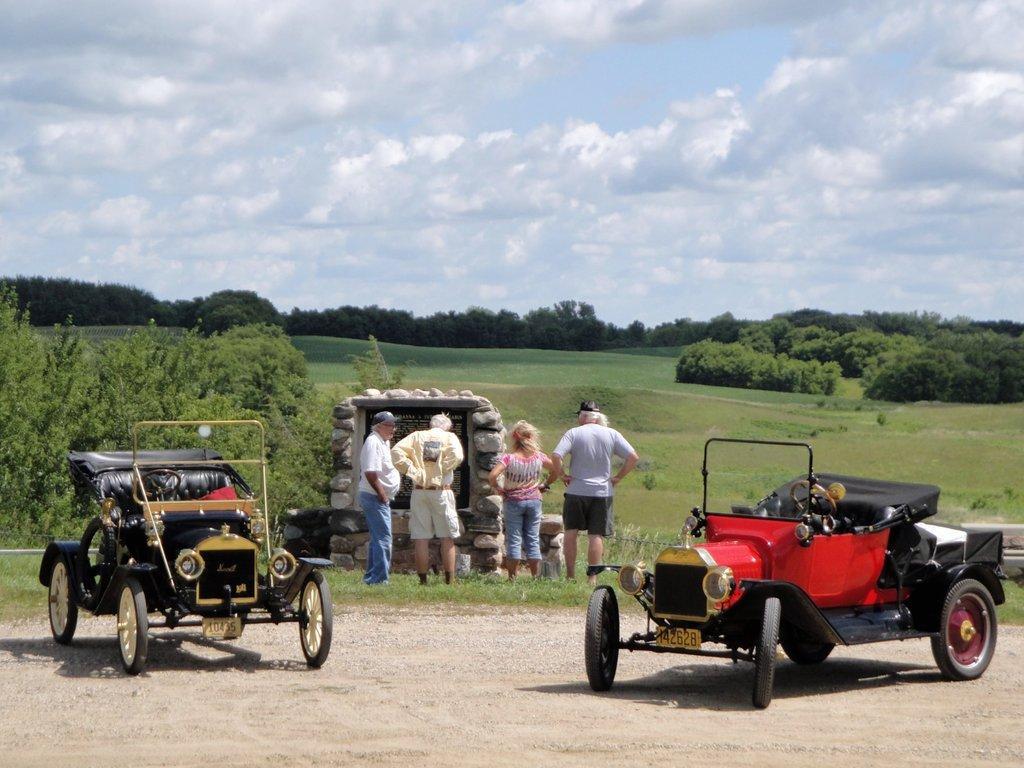Could you give a brief overview of what you see in this image? in this picture we can see few cars on the left and right side of the image, in the background we can find few people are standing on the grass, and also we can see few trees and clouds. 